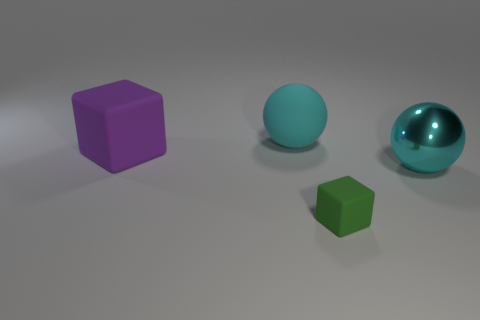Which objects in the image appear to have a texture, and can you describe it? Both the purple cube and the green cube exhibit a matt texture that is uniform and non-reflective, suggesting a smooth but non-glossy surface akin to rubber or a similar material. 